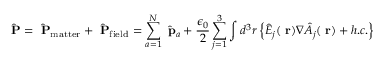<formula> <loc_0><loc_0><loc_500><loc_500>\hat { P } = \hat { P } _ { m a t t e r } + \hat { P } _ { f i e l d } = \sum _ { a = 1 } ^ { N } \hat { p } _ { a } + \frac { \epsilon _ { 0 } } { 2 } \sum _ { j = 1 } ^ { 3 } \int d ^ { 3 } r \left \{ \hat { E } _ { j } ( r ) \nabla \hat { A } _ { j } ( r ) + h . c . \right \}</formula> 